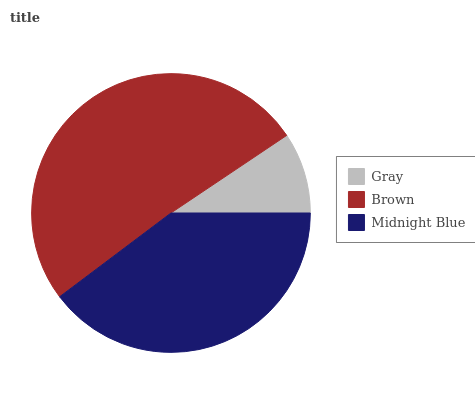Is Gray the minimum?
Answer yes or no. Yes. Is Brown the maximum?
Answer yes or no. Yes. Is Midnight Blue the minimum?
Answer yes or no. No. Is Midnight Blue the maximum?
Answer yes or no. No. Is Brown greater than Midnight Blue?
Answer yes or no. Yes. Is Midnight Blue less than Brown?
Answer yes or no. Yes. Is Midnight Blue greater than Brown?
Answer yes or no. No. Is Brown less than Midnight Blue?
Answer yes or no. No. Is Midnight Blue the high median?
Answer yes or no. Yes. Is Midnight Blue the low median?
Answer yes or no. Yes. Is Gray the high median?
Answer yes or no. No. Is Brown the low median?
Answer yes or no. No. 